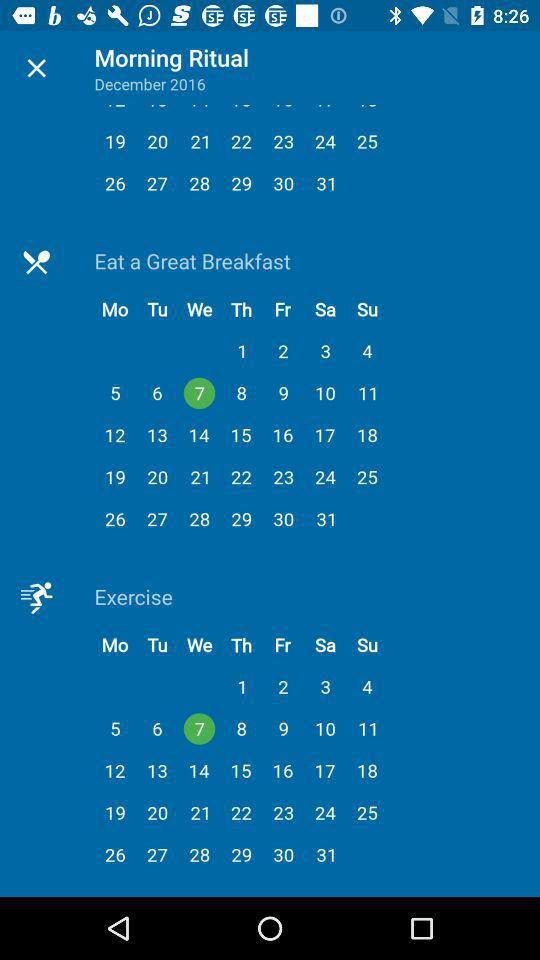What date is selected for exercise? The selected date for the exercise is Wednesday, December 7, 2016. 